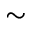Convert formula to latex. <formula><loc_0><loc_0><loc_500><loc_500>\sim</formula> 